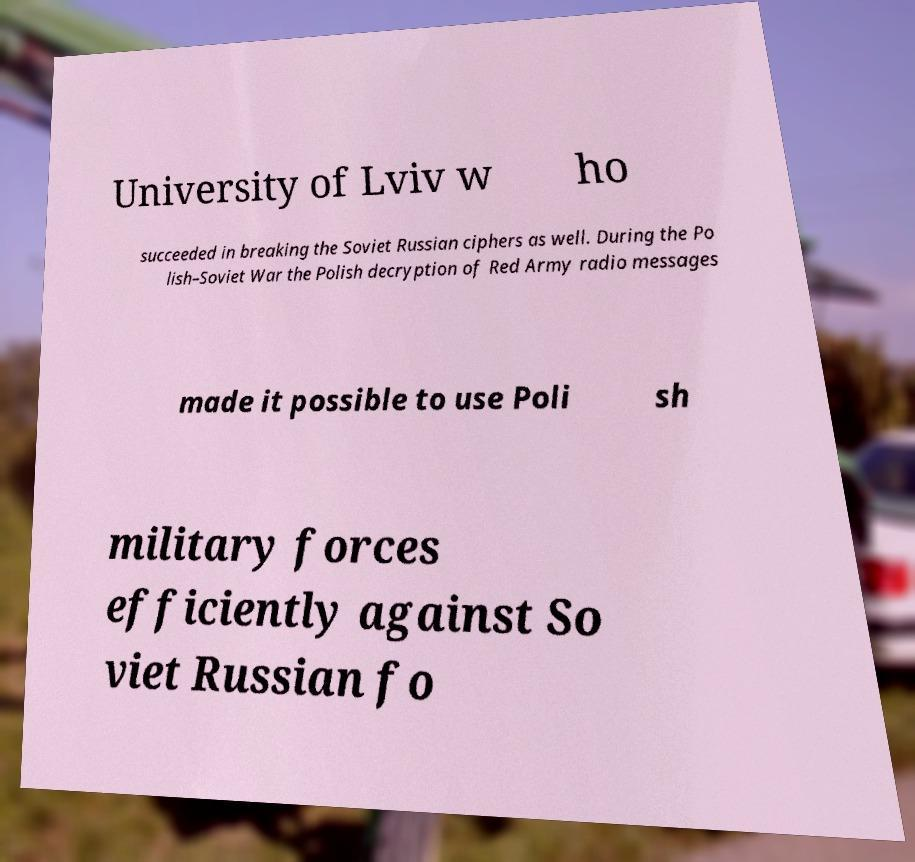There's text embedded in this image that I need extracted. Can you transcribe it verbatim? University of Lviv w ho succeeded in breaking the Soviet Russian ciphers as well. During the Po lish–Soviet War the Polish decryption of Red Army radio messages made it possible to use Poli sh military forces efficiently against So viet Russian fo 